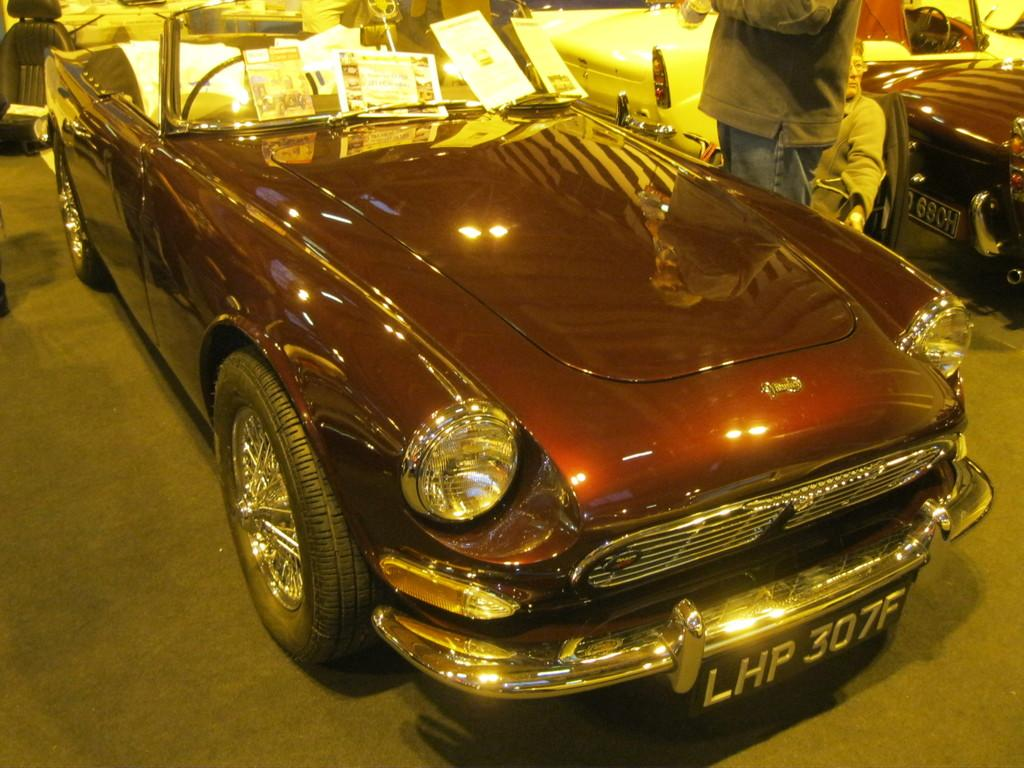What can be seen on the road in the image? There are cars on the road in the image. How many people are in the image? There are two people in the image. What are the positions of the people in the image? One person is sitting, and the other person is standing. What is inside the car in the image? There are posters inside the car. What type of building can be seen in the image? There is no building present in the image; it features cars on the road and two people. What attraction can be seen in the image? There is no attraction present in the image; it features cars on the road and two people. 